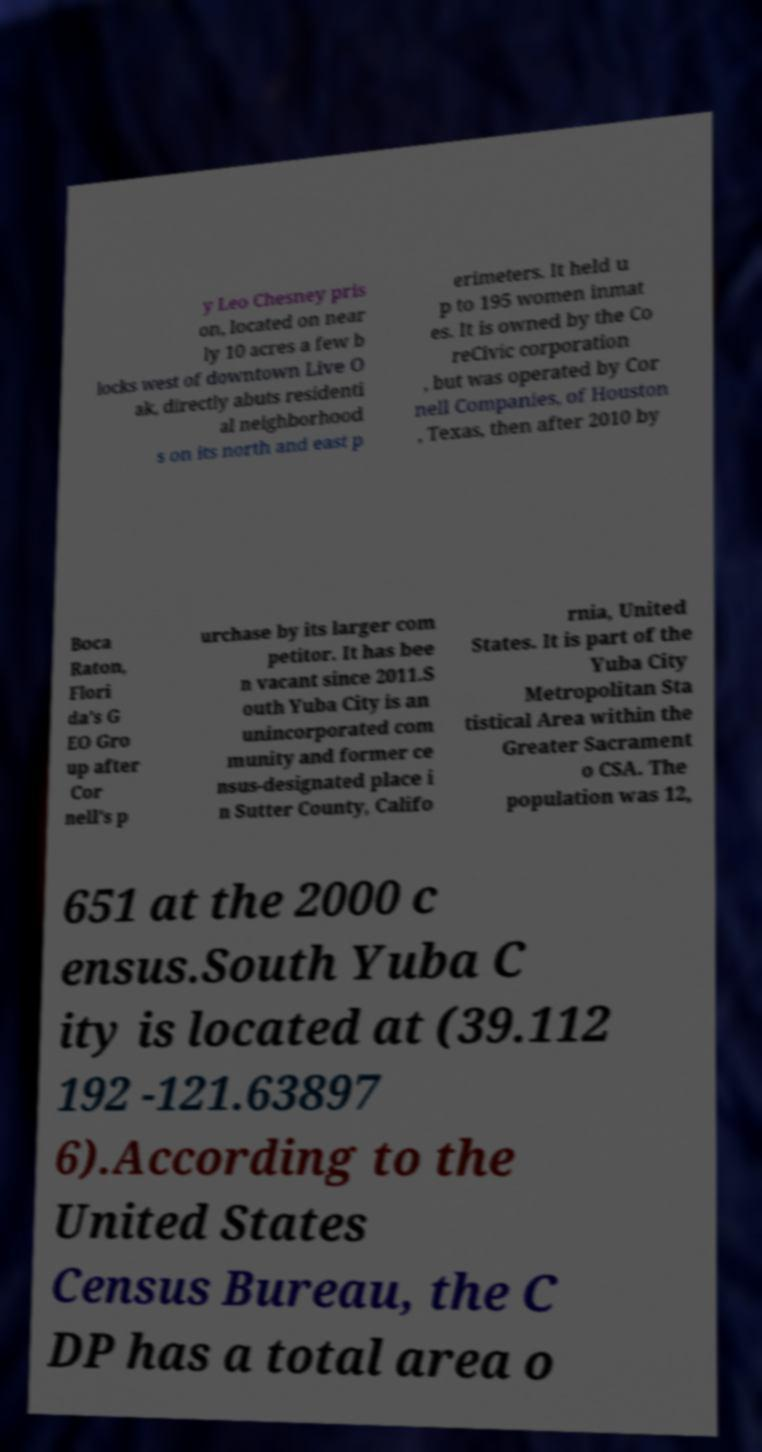For documentation purposes, I need the text within this image transcribed. Could you provide that? y Leo Chesney pris on, located on near ly 10 acres a few b locks west of downtown Live O ak, directly abuts residenti al neighborhood s on its north and east p erimeters. It held u p to 195 women inmat es. It is owned by the Co reCivic corporation , but was operated by Cor nell Companies, of Houston , Texas, then after 2010 by Boca Raton, Flori da's G EO Gro up after Cor nell's p urchase by its larger com petitor. It has bee n vacant since 2011.S outh Yuba City is an unincorporated com munity and former ce nsus-designated place i n Sutter County, Califo rnia, United States. It is part of the Yuba City Metropolitan Sta tistical Area within the Greater Sacrament o CSA. The population was 12, 651 at the 2000 c ensus.South Yuba C ity is located at (39.112 192 -121.63897 6).According to the United States Census Bureau, the C DP has a total area o 